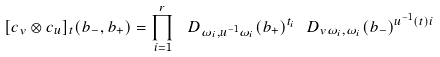Convert formula to latex. <formula><loc_0><loc_0><loc_500><loc_500>[ c _ { v } \otimes c _ { u } ] _ { t } ( b _ { - } , b _ { + } ) = \prod _ { i = 1 } ^ { r } \ D _ { \omega _ { i } , u ^ { - 1 } \omega _ { i } } ( b _ { + } ) ^ { t _ { i } } \ D _ { v \omega _ { i } , \omega _ { i } } ( b _ { - } ) ^ { u ^ { - 1 } ( t ) i }</formula> 